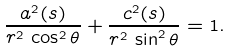<formula> <loc_0><loc_0><loc_500><loc_500>\frac { a ^ { 2 } ( s ) } { r ^ { 2 } \, \cos ^ { 2 } \theta } + \frac { c ^ { 2 } ( s ) } { r ^ { 2 } \, \sin ^ { 2 } \theta } = 1 .</formula> 